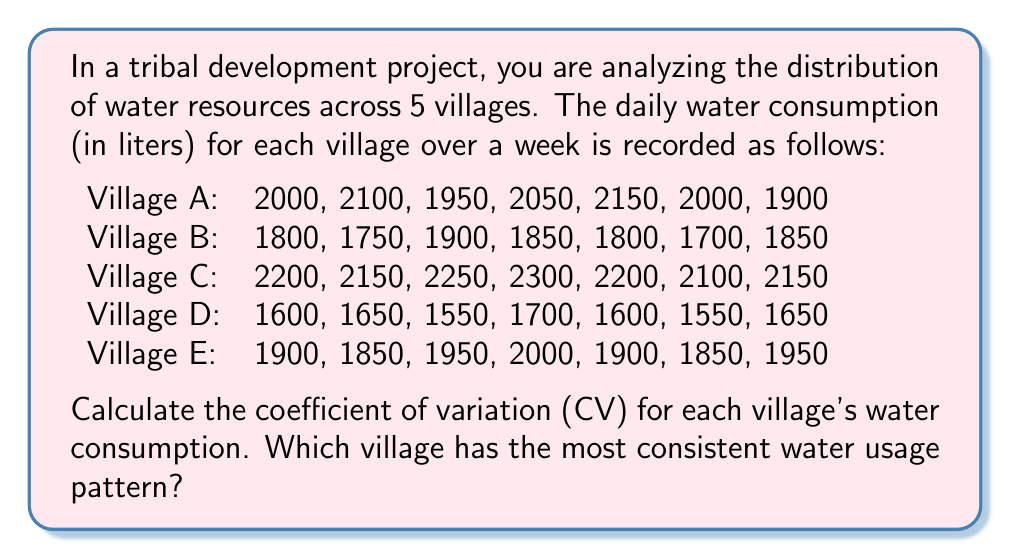Teach me how to tackle this problem. To solve this problem, we need to follow these steps for each village:

1. Calculate the mean (μ) of the water consumption
2. Calculate the standard deviation (σ) of the water consumption
3. Calculate the coefficient of variation (CV) using the formula: $CV = \frac{\sigma}{\mu} \times 100\%$

Let's go through this process for each village:

Village A:
1. Mean: $\mu_A = \frac{2000 + 2100 + 1950 + 2050 + 2150 + 2000 + 1900}{7} = 2021.43$ liters
2. Standard deviation: 
   $\sigma_A = \sqrt{\frac{\sum_{i=1}^7 (x_i - \mu_A)^2}{7-1}} = 94.49$ liters
3. $CV_A = \frac{94.49}{2021.43} \times 100\% = 4.67\%$

Village B:
1. $\mu_B = 1807.14$ liters
2. $\sigma_B = 70.34$ liters
3. $CV_B = 3.89\%$

Village C:
1. $\mu_C = 2192.86$ liters
2. $\sigma_C = 69.01$ liters
3. $CV_C = 3.15\%$

Village D:
1. $\mu_D = 1614.29$ liters
2. $\sigma_D = 55.63$ liters
3. $CV_D = 3.45\%$

Village E:
1. $\mu_E = 1914.29$ liters
2. $\sigma_E = 58.12$ liters
3. $CV_E = 3.04\%$

The coefficient of variation represents the ratio of the standard deviation to the mean and is a standardized measure of dispersion. A lower CV indicates more consistent data.

Comparing the CVs:
Village A: 4.67%
Village B: 3.89%
Village C: 3.15%
Village D: 3.45%
Village E: 3.04%

Village E has the lowest CV, indicating the most consistent water usage pattern.
Answer: Village E 